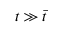Convert formula to latex. <formula><loc_0><loc_0><loc_500><loc_500>t \gg \bar { t }</formula> 